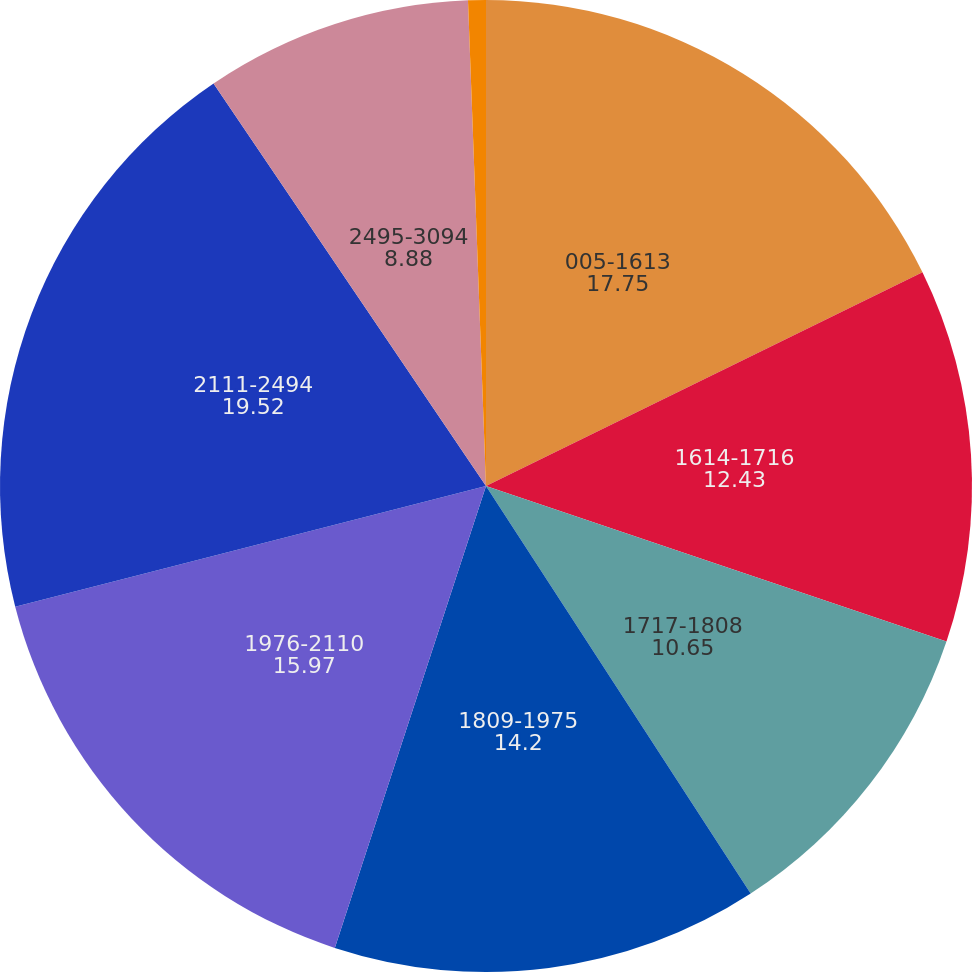Convert chart to OTSL. <chart><loc_0><loc_0><loc_500><loc_500><pie_chart><fcel>005-1613<fcel>1614-1716<fcel>1717-1808<fcel>1809-1975<fcel>1976-2110<fcel>2111-2494<fcel>2495-3094<fcel>3095 and over<nl><fcel>17.75%<fcel>12.43%<fcel>10.65%<fcel>14.2%<fcel>15.97%<fcel>19.52%<fcel>8.88%<fcel>0.59%<nl></chart> 